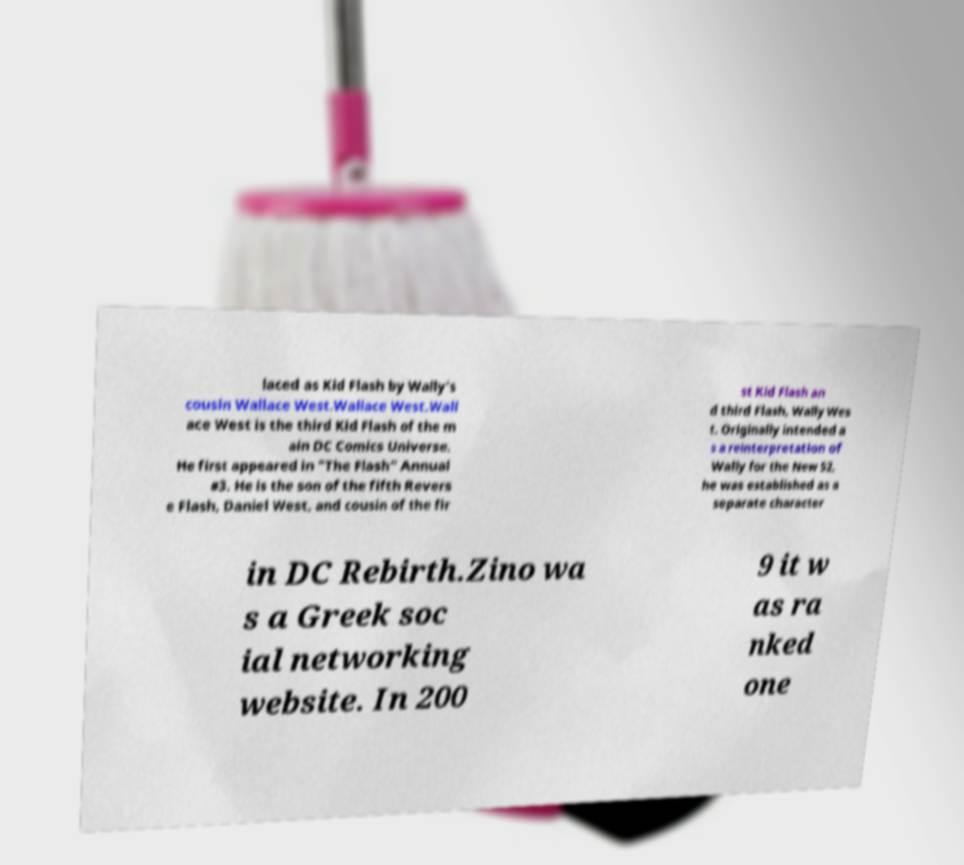Could you extract and type out the text from this image? laced as Kid Flash by Wally's cousin Wallace West.Wallace West.Wall ace West is the third Kid Flash of the m ain DC Comics Universe. He first appeared in "The Flash" Annual #3. He is the son of the fifth Revers e Flash, Daniel West, and cousin of the fir st Kid Flash an d third Flash, Wally Wes t. Originally intended a s a reinterpretation of Wally for the New 52, he was established as a separate character in DC Rebirth.Zino wa s a Greek soc ial networking website. In 200 9 it w as ra nked one 